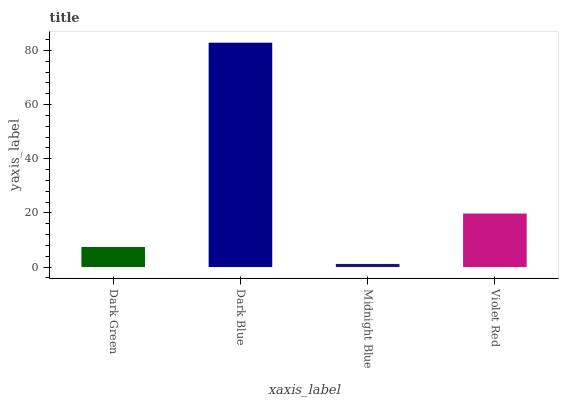Is Midnight Blue the minimum?
Answer yes or no. Yes. Is Dark Blue the maximum?
Answer yes or no. Yes. Is Dark Blue the minimum?
Answer yes or no. No. Is Midnight Blue the maximum?
Answer yes or no. No. Is Dark Blue greater than Midnight Blue?
Answer yes or no. Yes. Is Midnight Blue less than Dark Blue?
Answer yes or no. Yes. Is Midnight Blue greater than Dark Blue?
Answer yes or no. No. Is Dark Blue less than Midnight Blue?
Answer yes or no. No. Is Violet Red the high median?
Answer yes or no. Yes. Is Dark Green the low median?
Answer yes or no. Yes. Is Midnight Blue the high median?
Answer yes or no. No. Is Dark Blue the low median?
Answer yes or no. No. 